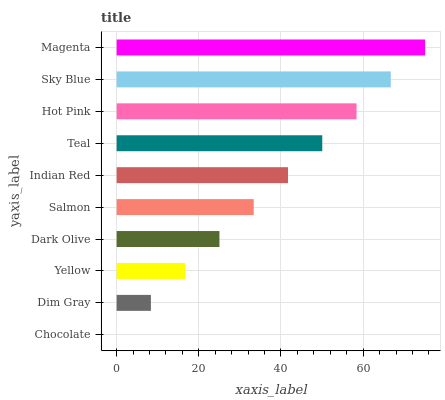Is Chocolate the minimum?
Answer yes or no. Yes. Is Magenta the maximum?
Answer yes or no. Yes. Is Dim Gray the minimum?
Answer yes or no. No. Is Dim Gray the maximum?
Answer yes or no. No. Is Dim Gray greater than Chocolate?
Answer yes or no. Yes. Is Chocolate less than Dim Gray?
Answer yes or no. Yes. Is Chocolate greater than Dim Gray?
Answer yes or no. No. Is Dim Gray less than Chocolate?
Answer yes or no. No. Is Indian Red the high median?
Answer yes or no. Yes. Is Salmon the low median?
Answer yes or no. Yes. Is Salmon the high median?
Answer yes or no. No. Is Hot Pink the low median?
Answer yes or no. No. 